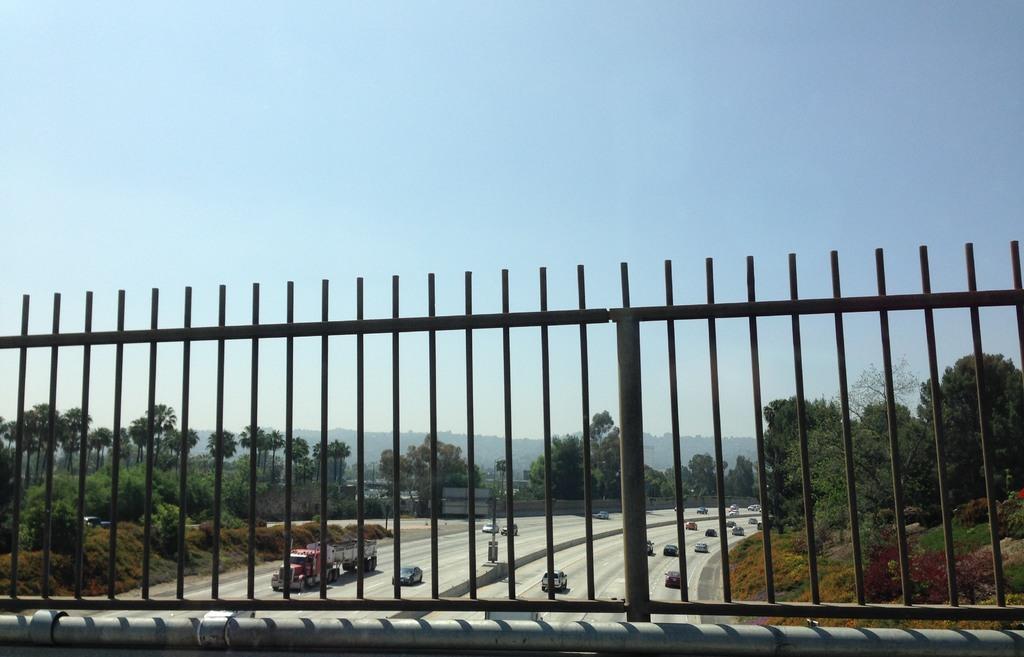Please provide a concise description of this image. There is a fencing near a pipe. In the background, there are vehicles on the road, there are trees, plants and grass on the ground, there is a mountain and there is blue sky. 